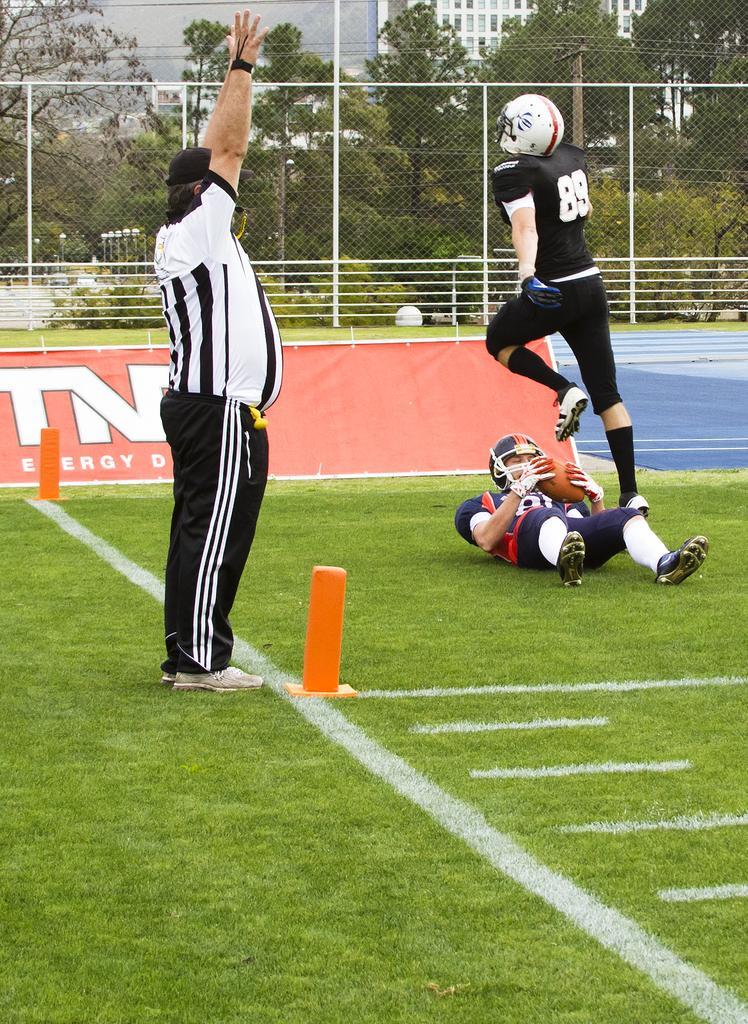Describe this image in one or two sentences. In this image we can see two persons wearing sports dress and one among them is lying on the ground and holding a ball and there is a person standing. We can see a fence and there are some trees and buildings in the background. 